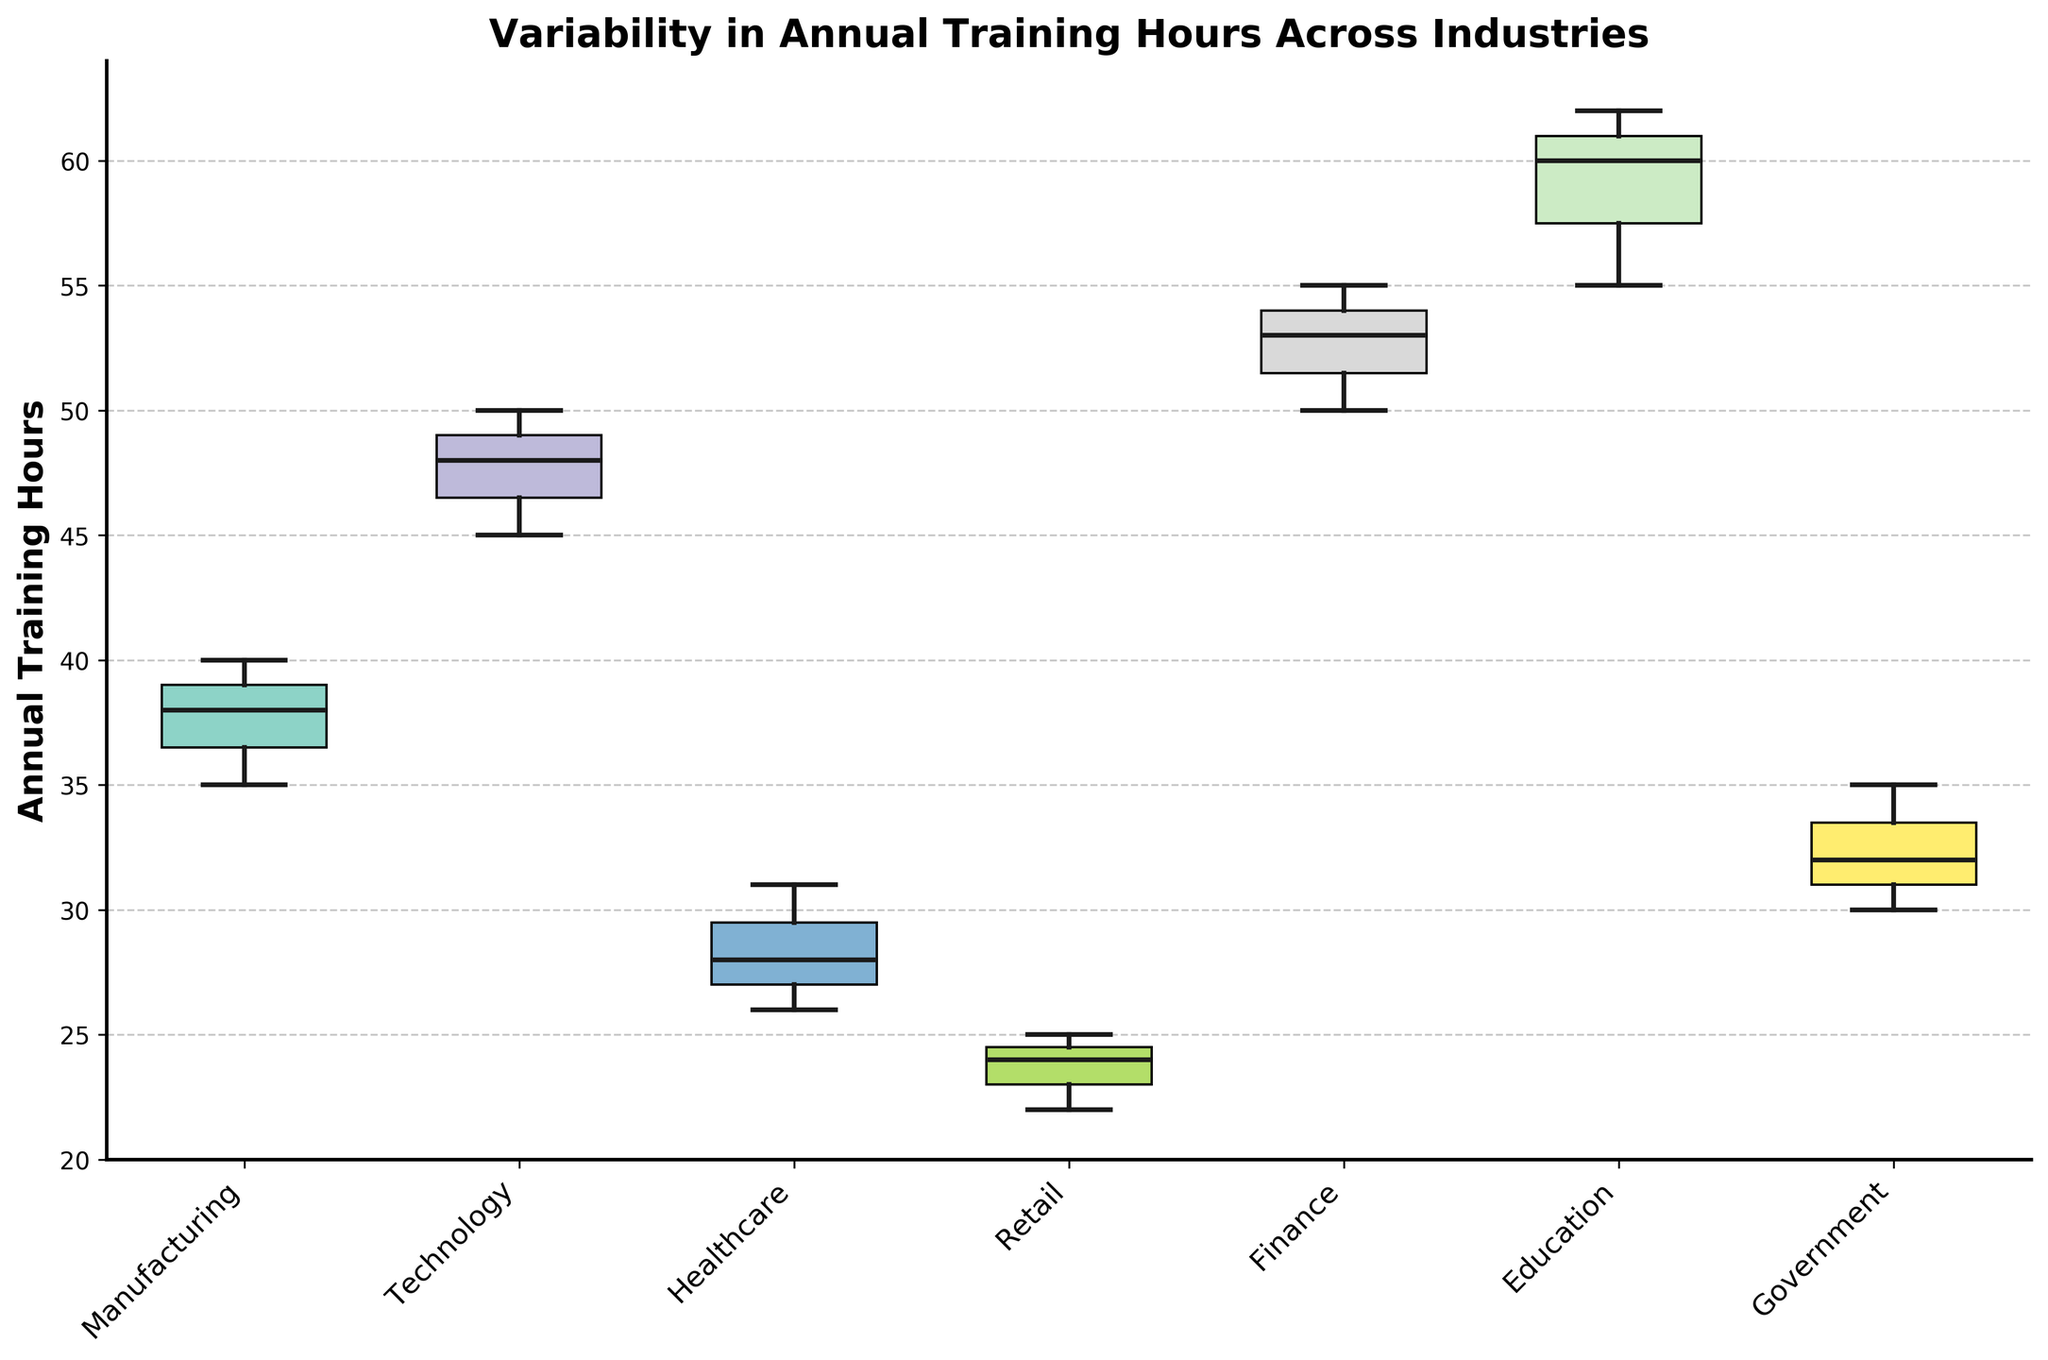What's the title of the plot? The title of the plot is found at the top center. It summarizes the content and purpose of the graph, which in this case is about variability in annual training hours.
Answer: Variability in Annual Training Hours Across Industries How many industries are represented in the plot? Look at the x-axis to count the number of distinct categories labeled on the tick marks, which represent different industries.
Answer: 7 What does the y-axis represent? The y-axis label, which is positioned on the left side of the plot, indicates what is being measured and compared across different industries.
Answer: Annual Training Hours Which industry has the highest median training hours? The median value is represented by the line inside the box for each industry. Identifying the industry where this line is highest gives the answer.
Answer: Education What is the range of training hours in the Retail industry? The range is the difference between the maximum and minimum values, indicated by the top and bottom whiskers of the box plot for the Retail industry.
Answer: 22 - 25 Which industry shows the widest variability in annual training hours? The industry with the widest box and/or longest whiskers indicates the greatest variability.
Answer: Education How does the median training hours in Manufacturing compare to Finance? Compare the positions of the median lines (inside the boxes) of Manufacturing and Finance to determine if one is higher or lower than the other.
Answer: Finance has a higher median than Manufacturing Which industry has the most consistent annual training hours across companies? The industry with the smallest box and shortest whiskers represents the most consistency.
Answer: Retail What's the interquartile range (IQR) for the Technology industry? The IQR is the range between the first quartile (bottom edge of the box) and the third quartile (top edge of the box). Measure this distance visually on the plot for Technology.
Answer: 45 - 50 Is Healthcare more variable than Government in terms of annual training hours? Compare the lengths of the boxes and whiskers for Healthcare and Government to determine which shows more spread or variability in values.
Answer: Yes, Healthcare is more variable than Government 